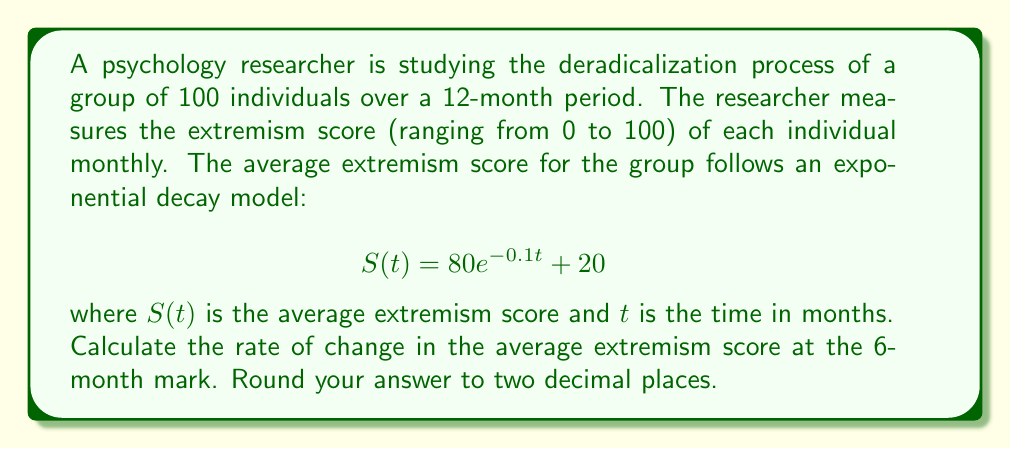Could you help me with this problem? To find the rate of change in the average extremism score at the 6-month mark, we need to calculate the derivative of the given function $S(t)$ and evaluate it at $t=6$.

Step 1: Find the derivative of $S(t)$
$$S(t) = 80e^{-0.1t} + 20$$
$$\frac{dS}{dt} = 80 \cdot (-0.1) \cdot e^{-0.1t} + 0$$
$$\frac{dS}{dt} = -8e^{-0.1t}$$

Step 2: Evaluate the derivative at $t=6$
$$\frac{dS}{dt}\bigg|_{t=6} = -8e^{-0.1(6)}$$
$$\frac{dS}{dt}\bigg|_{t=6} = -8e^{-0.6}$$

Step 3: Calculate the value
$$\frac{dS}{dt}\bigg|_{t=6} = -8 \cdot 0.54881164...$$
$$\frac{dS}{dt}\bigg|_{t=6} = -4.39049312...$$

Step 4: Round to two decimal places
$$\frac{dS}{dt}\bigg|_{t=6} \approx -4.39$$

The negative value indicates that the average extremism score is decreasing at the 6-month mark.
Answer: -4.39 